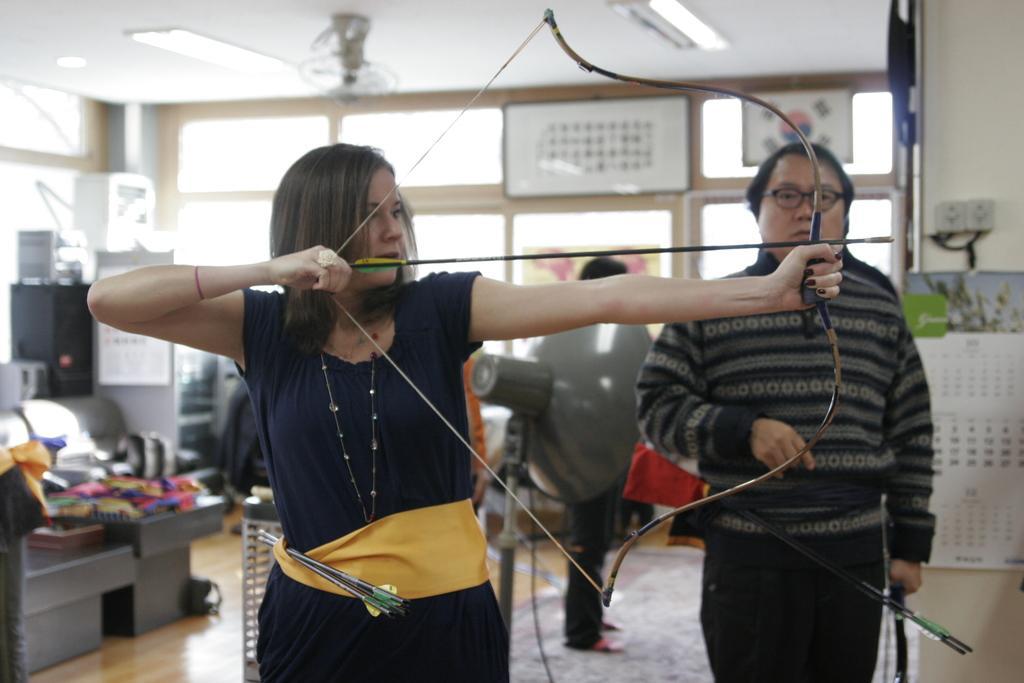Could you give a brief overview of what you see in this image? This is the woman standing and holding a bow and an arrow. Here is the man standing. This looks like a calendar, which is hanging to the wall. These are the frames, which are attached to the glass doors. This looks like a machine. I can see few objects placed on the bench. Here is the other person standing. I can see the ceiling lights and a ceiling fan at the top. 